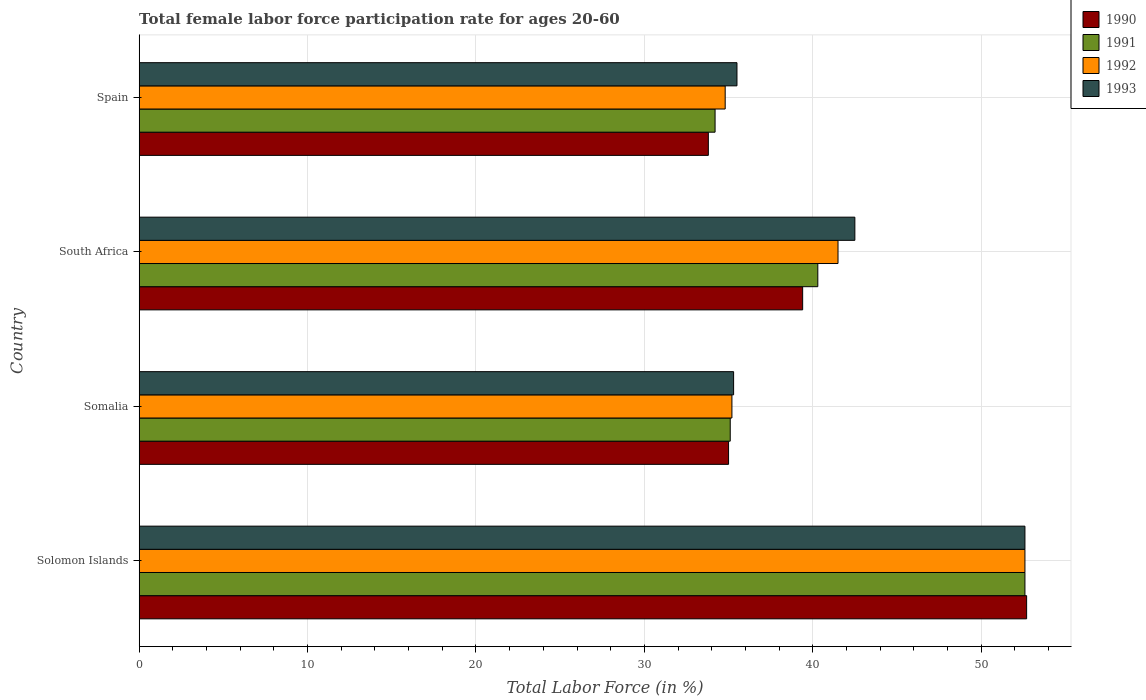How many groups of bars are there?
Your answer should be compact. 4. Are the number of bars on each tick of the Y-axis equal?
Give a very brief answer. Yes. How many bars are there on the 4th tick from the bottom?
Give a very brief answer. 4. What is the label of the 3rd group of bars from the top?
Provide a short and direct response. Somalia. In how many cases, is the number of bars for a given country not equal to the number of legend labels?
Your response must be concise. 0. What is the female labor force participation rate in 1990 in Spain?
Ensure brevity in your answer.  33.8. Across all countries, what is the maximum female labor force participation rate in 1993?
Make the answer very short. 52.6. Across all countries, what is the minimum female labor force participation rate in 1991?
Your answer should be very brief. 34.2. In which country was the female labor force participation rate in 1990 maximum?
Keep it short and to the point. Solomon Islands. In which country was the female labor force participation rate in 1993 minimum?
Ensure brevity in your answer.  Somalia. What is the total female labor force participation rate in 1993 in the graph?
Offer a very short reply. 165.9. What is the difference between the female labor force participation rate in 1993 in Solomon Islands and that in Somalia?
Provide a short and direct response. 17.3. What is the average female labor force participation rate in 1992 per country?
Provide a succinct answer. 41.02. What is the difference between the female labor force participation rate in 1990 and female labor force participation rate in 1993 in Somalia?
Your response must be concise. -0.3. What is the ratio of the female labor force participation rate in 1993 in Solomon Islands to that in South Africa?
Keep it short and to the point. 1.24. Is the female labor force participation rate in 1990 in Somalia less than that in South Africa?
Your answer should be compact. Yes. Is the difference between the female labor force participation rate in 1990 in Solomon Islands and South Africa greater than the difference between the female labor force participation rate in 1993 in Solomon Islands and South Africa?
Your answer should be compact. Yes. What is the difference between the highest and the second highest female labor force participation rate in 1992?
Your answer should be compact. 11.1. What is the difference between the highest and the lowest female labor force participation rate in 1991?
Offer a terse response. 18.4. In how many countries, is the female labor force participation rate in 1990 greater than the average female labor force participation rate in 1990 taken over all countries?
Give a very brief answer. 1. Is it the case that in every country, the sum of the female labor force participation rate in 1990 and female labor force participation rate in 1992 is greater than the sum of female labor force participation rate in 1993 and female labor force participation rate in 1991?
Keep it short and to the point. No. What does the 3rd bar from the bottom in Spain represents?
Ensure brevity in your answer.  1992. How many bars are there?
Ensure brevity in your answer.  16. Are all the bars in the graph horizontal?
Keep it short and to the point. Yes. How many countries are there in the graph?
Your answer should be compact. 4. What is the difference between two consecutive major ticks on the X-axis?
Your response must be concise. 10. Does the graph contain grids?
Your response must be concise. Yes. What is the title of the graph?
Offer a very short reply. Total female labor force participation rate for ages 20-60. What is the label or title of the Y-axis?
Your response must be concise. Country. What is the Total Labor Force (in %) of 1990 in Solomon Islands?
Your answer should be compact. 52.7. What is the Total Labor Force (in %) in 1991 in Solomon Islands?
Keep it short and to the point. 52.6. What is the Total Labor Force (in %) of 1992 in Solomon Islands?
Provide a succinct answer. 52.6. What is the Total Labor Force (in %) of 1993 in Solomon Islands?
Your answer should be compact. 52.6. What is the Total Labor Force (in %) of 1991 in Somalia?
Provide a succinct answer. 35.1. What is the Total Labor Force (in %) in 1992 in Somalia?
Your answer should be compact. 35.2. What is the Total Labor Force (in %) of 1993 in Somalia?
Your answer should be very brief. 35.3. What is the Total Labor Force (in %) in 1990 in South Africa?
Offer a terse response. 39.4. What is the Total Labor Force (in %) of 1991 in South Africa?
Make the answer very short. 40.3. What is the Total Labor Force (in %) in 1992 in South Africa?
Make the answer very short. 41.5. What is the Total Labor Force (in %) of 1993 in South Africa?
Give a very brief answer. 42.5. What is the Total Labor Force (in %) in 1990 in Spain?
Your response must be concise. 33.8. What is the Total Labor Force (in %) of 1991 in Spain?
Provide a succinct answer. 34.2. What is the Total Labor Force (in %) of 1992 in Spain?
Make the answer very short. 34.8. What is the Total Labor Force (in %) of 1993 in Spain?
Give a very brief answer. 35.5. Across all countries, what is the maximum Total Labor Force (in %) in 1990?
Offer a very short reply. 52.7. Across all countries, what is the maximum Total Labor Force (in %) in 1991?
Ensure brevity in your answer.  52.6. Across all countries, what is the maximum Total Labor Force (in %) in 1992?
Offer a terse response. 52.6. Across all countries, what is the maximum Total Labor Force (in %) in 1993?
Your response must be concise. 52.6. Across all countries, what is the minimum Total Labor Force (in %) of 1990?
Offer a terse response. 33.8. Across all countries, what is the minimum Total Labor Force (in %) of 1991?
Your answer should be compact. 34.2. Across all countries, what is the minimum Total Labor Force (in %) of 1992?
Keep it short and to the point. 34.8. Across all countries, what is the minimum Total Labor Force (in %) in 1993?
Ensure brevity in your answer.  35.3. What is the total Total Labor Force (in %) of 1990 in the graph?
Keep it short and to the point. 160.9. What is the total Total Labor Force (in %) in 1991 in the graph?
Offer a terse response. 162.2. What is the total Total Labor Force (in %) in 1992 in the graph?
Provide a succinct answer. 164.1. What is the total Total Labor Force (in %) in 1993 in the graph?
Offer a terse response. 165.9. What is the difference between the Total Labor Force (in %) in 1990 in Solomon Islands and that in Somalia?
Offer a very short reply. 17.7. What is the difference between the Total Labor Force (in %) of 1991 in Solomon Islands and that in Somalia?
Offer a terse response. 17.5. What is the difference between the Total Labor Force (in %) of 1992 in Solomon Islands and that in Somalia?
Offer a very short reply. 17.4. What is the difference between the Total Labor Force (in %) of 1993 in Solomon Islands and that in Somalia?
Your answer should be compact. 17.3. What is the difference between the Total Labor Force (in %) of 1991 in Solomon Islands and that in South Africa?
Your answer should be compact. 12.3. What is the difference between the Total Labor Force (in %) of 1992 in Solomon Islands and that in South Africa?
Make the answer very short. 11.1. What is the difference between the Total Labor Force (in %) of 1993 in Solomon Islands and that in South Africa?
Keep it short and to the point. 10.1. What is the difference between the Total Labor Force (in %) in 1990 in Solomon Islands and that in Spain?
Provide a succinct answer. 18.9. What is the difference between the Total Labor Force (in %) in 1993 in Solomon Islands and that in Spain?
Provide a succinct answer. 17.1. What is the difference between the Total Labor Force (in %) of 1991 in Somalia and that in South Africa?
Give a very brief answer. -5.2. What is the difference between the Total Labor Force (in %) of 1993 in Somalia and that in South Africa?
Give a very brief answer. -7.2. What is the difference between the Total Labor Force (in %) in 1991 in Somalia and that in Spain?
Your response must be concise. 0.9. What is the difference between the Total Labor Force (in %) in 1992 in Somalia and that in Spain?
Your answer should be compact. 0.4. What is the difference between the Total Labor Force (in %) in 1990 in South Africa and that in Spain?
Provide a short and direct response. 5.6. What is the difference between the Total Labor Force (in %) in 1992 in South Africa and that in Spain?
Ensure brevity in your answer.  6.7. What is the difference between the Total Labor Force (in %) in 1993 in South Africa and that in Spain?
Your answer should be very brief. 7. What is the difference between the Total Labor Force (in %) in 1990 in Solomon Islands and the Total Labor Force (in %) in 1991 in Somalia?
Offer a terse response. 17.6. What is the difference between the Total Labor Force (in %) in 1991 in Solomon Islands and the Total Labor Force (in %) in 1993 in Somalia?
Give a very brief answer. 17.3. What is the difference between the Total Labor Force (in %) of 1992 in Solomon Islands and the Total Labor Force (in %) of 1993 in Somalia?
Your response must be concise. 17.3. What is the difference between the Total Labor Force (in %) of 1990 in Solomon Islands and the Total Labor Force (in %) of 1992 in South Africa?
Provide a succinct answer. 11.2. What is the difference between the Total Labor Force (in %) in 1990 in Solomon Islands and the Total Labor Force (in %) in 1993 in South Africa?
Offer a very short reply. 10.2. What is the difference between the Total Labor Force (in %) in 1991 in Solomon Islands and the Total Labor Force (in %) in 1993 in South Africa?
Offer a very short reply. 10.1. What is the difference between the Total Labor Force (in %) of 1990 in Solomon Islands and the Total Labor Force (in %) of 1991 in Spain?
Your response must be concise. 18.5. What is the difference between the Total Labor Force (in %) in 1990 in Solomon Islands and the Total Labor Force (in %) in 1992 in Spain?
Provide a succinct answer. 17.9. What is the difference between the Total Labor Force (in %) in 1991 in Solomon Islands and the Total Labor Force (in %) in 1992 in Spain?
Keep it short and to the point. 17.8. What is the difference between the Total Labor Force (in %) in 1991 in Solomon Islands and the Total Labor Force (in %) in 1993 in Spain?
Offer a very short reply. 17.1. What is the difference between the Total Labor Force (in %) in 1992 in Solomon Islands and the Total Labor Force (in %) in 1993 in Spain?
Provide a succinct answer. 17.1. What is the difference between the Total Labor Force (in %) of 1990 in Somalia and the Total Labor Force (in %) of 1991 in South Africa?
Provide a short and direct response. -5.3. What is the difference between the Total Labor Force (in %) in 1990 in Somalia and the Total Labor Force (in %) in 1992 in South Africa?
Your answer should be compact. -6.5. What is the difference between the Total Labor Force (in %) of 1991 in Somalia and the Total Labor Force (in %) of 1993 in South Africa?
Your answer should be compact. -7.4. What is the difference between the Total Labor Force (in %) of 1990 in Somalia and the Total Labor Force (in %) of 1992 in Spain?
Offer a terse response. 0.2. What is the difference between the Total Labor Force (in %) in 1990 in Somalia and the Total Labor Force (in %) in 1993 in Spain?
Your answer should be very brief. -0.5. What is the difference between the Total Labor Force (in %) of 1991 in Somalia and the Total Labor Force (in %) of 1992 in Spain?
Ensure brevity in your answer.  0.3. What is the difference between the Total Labor Force (in %) in 1991 in Somalia and the Total Labor Force (in %) in 1993 in Spain?
Give a very brief answer. -0.4. What is the difference between the Total Labor Force (in %) in 1992 in Somalia and the Total Labor Force (in %) in 1993 in Spain?
Your response must be concise. -0.3. What is the difference between the Total Labor Force (in %) in 1990 in South Africa and the Total Labor Force (in %) in 1991 in Spain?
Make the answer very short. 5.2. What is the difference between the Total Labor Force (in %) of 1992 in South Africa and the Total Labor Force (in %) of 1993 in Spain?
Provide a short and direct response. 6. What is the average Total Labor Force (in %) in 1990 per country?
Offer a very short reply. 40.23. What is the average Total Labor Force (in %) in 1991 per country?
Your answer should be compact. 40.55. What is the average Total Labor Force (in %) in 1992 per country?
Your answer should be compact. 41.02. What is the average Total Labor Force (in %) in 1993 per country?
Ensure brevity in your answer.  41.48. What is the difference between the Total Labor Force (in %) of 1991 and Total Labor Force (in %) of 1992 in Solomon Islands?
Your response must be concise. 0. What is the difference between the Total Labor Force (in %) in 1991 and Total Labor Force (in %) in 1993 in Solomon Islands?
Offer a very short reply. 0. What is the difference between the Total Labor Force (in %) in 1992 and Total Labor Force (in %) in 1993 in Solomon Islands?
Offer a terse response. 0. What is the difference between the Total Labor Force (in %) in 1990 and Total Labor Force (in %) in 1991 in Somalia?
Keep it short and to the point. -0.1. What is the difference between the Total Labor Force (in %) of 1990 and Total Labor Force (in %) of 1993 in Somalia?
Make the answer very short. -0.3. What is the difference between the Total Labor Force (in %) in 1991 and Total Labor Force (in %) in 1992 in Somalia?
Give a very brief answer. -0.1. What is the difference between the Total Labor Force (in %) in 1991 and Total Labor Force (in %) in 1993 in Somalia?
Your answer should be compact. -0.2. What is the difference between the Total Labor Force (in %) of 1990 and Total Labor Force (in %) of 1991 in South Africa?
Your answer should be very brief. -0.9. What is the difference between the Total Labor Force (in %) of 1990 and Total Labor Force (in %) of 1992 in Spain?
Your answer should be very brief. -1. What is the difference between the Total Labor Force (in %) of 1990 and Total Labor Force (in %) of 1993 in Spain?
Offer a terse response. -1.7. What is the difference between the Total Labor Force (in %) of 1992 and Total Labor Force (in %) of 1993 in Spain?
Offer a terse response. -0.7. What is the ratio of the Total Labor Force (in %) of 1990 in Solomon Islands to that in Somalia?
Make the answer very short. 1.51. What is the ratio of the Total Labor Force (in %) of 1991 in Solomon Islands to that in Somalia?
Your answer should be compact. 1.5. What is the ratio of the Total Labor Force (in %) in 1992 in Solomon Islands to that in Somalia?
Your answer should be very brief. 1.49. What is the ratio of the Total Labor Force (in %) of 1993 in Solomon Islands to that in Somalia?
Your answer should be compact. 1.49. What is the ratio of the Total Labor Force (in %) in 1990 in Solomon Islands to that in South Africa?
Offer a very short reply. 1.34. What is the ratio of the Total Labor Force (in %) in 1991 in Solomon Islands to that in South Africa?
Offer a very short reply. 1.31. What is the ratio of the Total Labor Force (in %) in 1992 in Solomon Islands to that in South Africa?
Your answer should be compact. 1.27. What is the ratio of the Total Labor Force (in %) in 1993 in Solomon Islands to that in South Africa?
Offer a terse response. 1.24. What is the ratio of the Total Labor Force (in %) of 1990 in Solomon Islands to that in Spain?
Make the answer very short. 1.56. What is the ratio of the Total Labor Force (in %) in 1991 in Solomon Islands to that in Spain?
Keep it short and to the point. 1.54. What is the ratio of the Total Labor Force (in %) in 1992 in Solomon Islands to that in Spain?
Provide a short and direct response. 1.51. What is the ratio of the Total Labor Force (in %) in 1993 in Solomon Islands to that in Spain?
Provide a short and direct response. 1.48. What is the ratio of the Total Labor Force (in %) of 1990 in Somalia to that in South Africa?
Make the answer very short. 0.89. What is the ratio of the Total Labor Force (in %) in 1991 in Somalia to that in South Africa?
Provide a short and direct response. 0.87. What is the ratio of the Total Labor Force (in %) of 1992 in Somalia to that in South Africa?
Your answer should be very brief. 0.85. What is the ratio of the Total Labor Force (in %) in 1993 in Somalia to that in South Africa?
Give a very brief answer. 0.83. What is the ratio of the Total Labor Force (in %) of 1990 in Somalia to that in Spain?
Provide a succinct answer. 1.04. What is the ratio of the Total Labor Force (in %) of 1991 in Somalia to that in Spain?
Your answer should be compact. 1.03. What is the ratio of the Total Labor Force (in %) of 1992 in Somalia to that in Spain?
Your response must be concise. 1.01. What is the ratio of the Total Labor Force (in %) of 1990 in South Africa to that in Spain?
Provide a succinct answer. 1.17. What is the ratio of the Total Labor Force (in %) of 1991 in South Africa to that in Spain?
Your response must be concise. 1.18. What is the ratio of the Total Labor Force (in %) in 1992 in South Africa to that in Spain?
Keep it short and to the point. 1.19. What is the ratio of the Total Labor Force (in %) of 1993 in South Africa to that in Spain?
Make the answer very short. 1.2. What is the difference between the highest and the second highest Total Labor Force (in %) in 1993?
Your answer should be very brief. 10.1. What is the difference between the highest and the lowest Total Labor Force (in %) in 1990?
Make the answer very short. 18.9. What is the difference between the highest and the lowest Total Labor Force (in %) of 1991?
Make the answer very short. 18.4. What is the difference between the highest and the lowest Total Labor Force (in %) in 1993?
Keep it short and to the point. 17.3. 